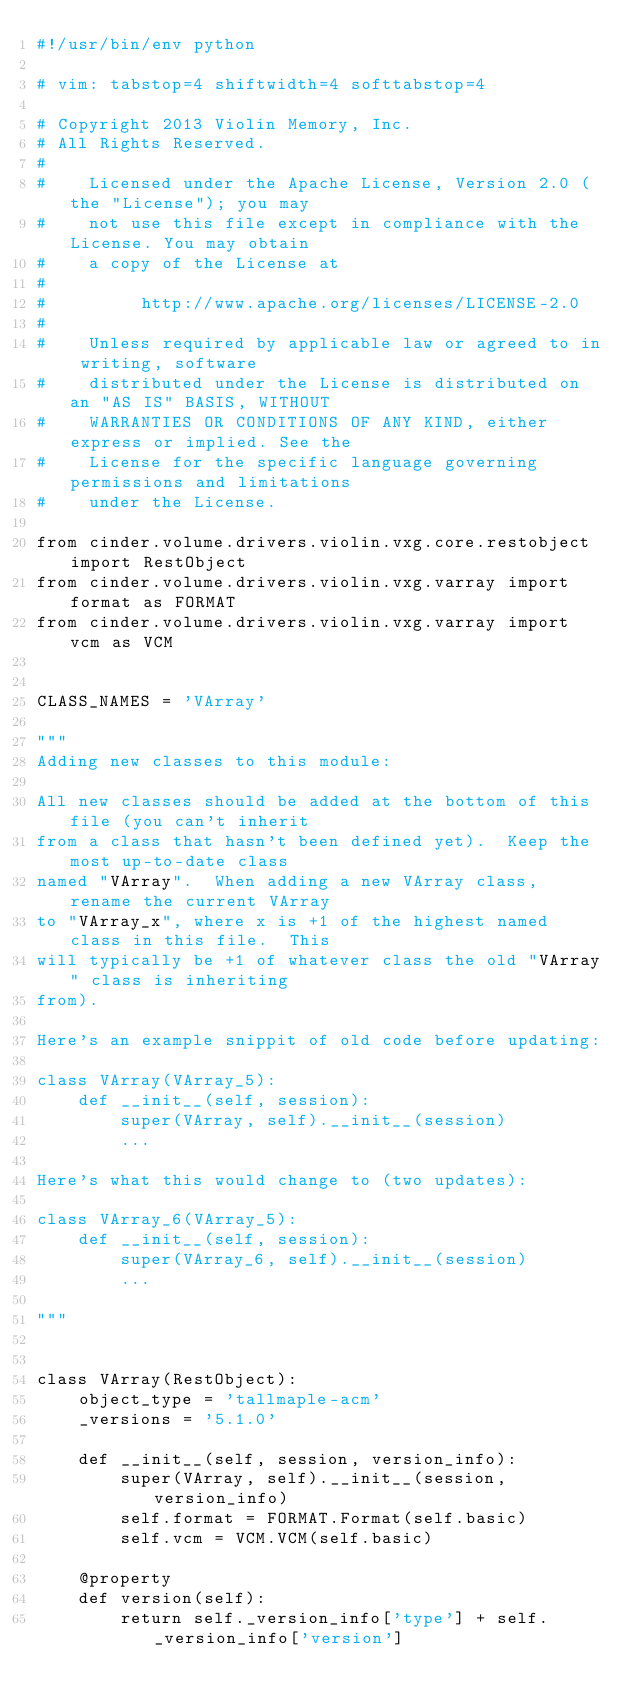Convert code to text. <code><loc_0><loc_0><loc_500><loc_500><_Python_>#!/usr/bin/env python

# vim: tabstop=4 shiftwidth=4 softtabstop=4

# Copyright 2013 Violin Memory, Inc.
# All Rights Reserved.
#
#    Licensed under the Apache License, Version 2.0 (the "License"); you may
#    not use this file except in compliance with the License. You may obtain
#    a copy of the License at
#
#         http://www.apache.org/licenses/LICENSE-2.0
#
#    Unless required by applicable law or agreed to in writing, software
#    distributed under the License is distributed on an "AS IS" BASIS, WITHOUT
#    WARRANTIES OR CONDITIONS OF ANY KIND, either express or implied. See the
#    License for the specific language governing permissions and limitations
#    under the License.

from cinder.volume.drivers.violin.vxg.core.restobject import RestObject
from cinder.volume.drivers.violin.vxg.varray import format as FORMAT
from cinder.volume.drivers.violin.vxg.varray import vcm as VCM


CLASS_NAMES = 'VArray'

"""
Adding new classes to this module:

All new classes should be added at the bottom of this file (you can't inherit
from a class that hasn't been defined yet).  Keep the most up-to-date class
named "VArray".  When adding a new VArray class, rename the current VArray
to "VArray_x", where x is +1 of the highest named class in this file.  This
will typically be +1 of whatever class the old "VArray" class is inheriting
from).

Here's an example snippit of old code before updating:

class VArray(VArray_5):
    def __init__(self, session):
        super(VArray, self).__init__(session)
        ...

Here's what this would change to (two updates):

class VArray_6(VArray_5):
    def __init__(self, session):
        super(VArray_6, self).__init__(session)
        ...

"""


class VArray(RestObject):
    object_type = 'tallmaple-acm'
    _versions = '5.1.0'

    def __init__(self, session, version_info):
        super(VArray, self).__init__(session, version_info)
        self.format = FORMAT.Format(self.basic)
        self.vcm = VCM.VCM(self.basic)

    @property
    def version(self):
        return self._version_info['type'] + self._version_info['version']
</code> 